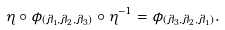Convert formula to latex. <formula><loc_0><loc_0><loc_500><loc_500>\eta \circ \phi _ { ( \lambda _ { 1 } , \lambda _ { 2 } , \lambda _ { 3 } ) } \circ \eta ^ { - 1 } = \phi _ { ( \lambda _ { 3 } , \lambda _ { 2 } , \lambda _ { 1 } ) } .</formula> 